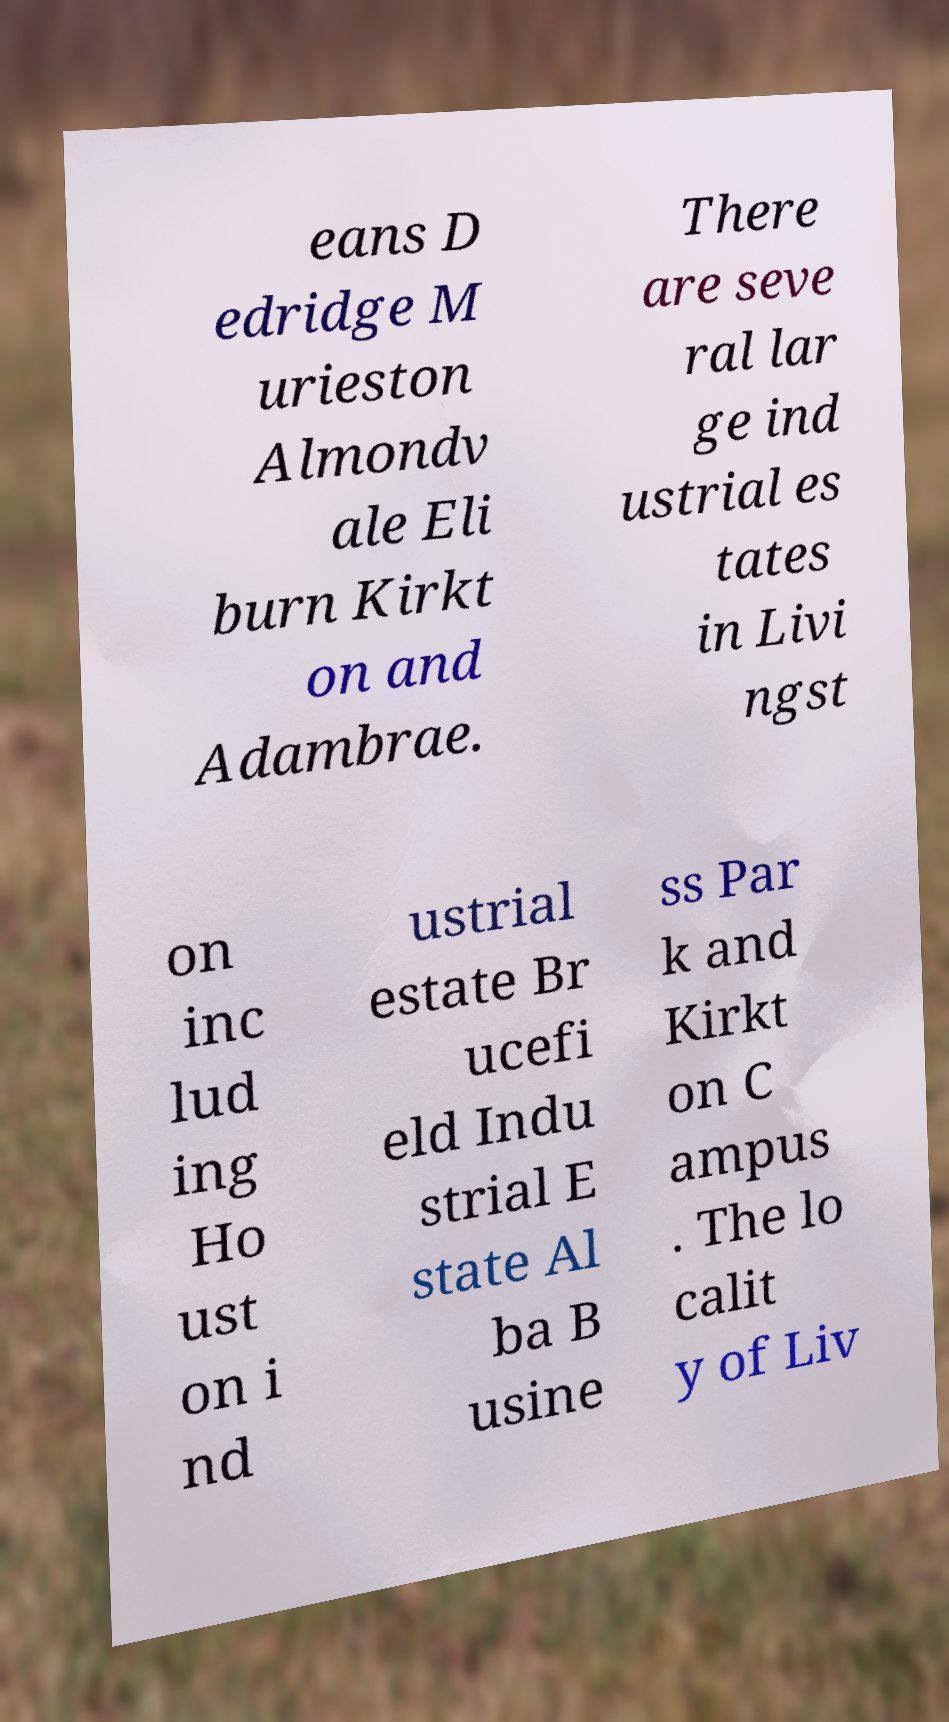Could you extract and type out the text from this image? eans D edridge M urieston Almondv ale Eli burn Kirkt on and Adambrae. There are seve ral lar ge ind ustrial es tates in Livi ngst on inc lud ing Ho ust on i nd ustrial estate Br ucefi eld Indu strial E state Al ba B usine ss Par k and Kirkt on C ampus . The lo calit y of Liv 